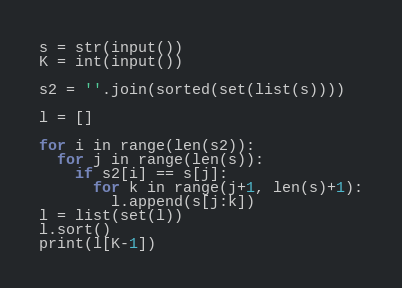Convert code to text. <code><loc_0><loc_0><loc_500><loc_500><_Python_>s = str(input())
K = int(input())

s2 = ''.join(sorted(set(list(s))))

l = []

for i in range(len(s2)):
  for j in range(len(s)):
    if s2[i] == s[j]:
      for k in range(j+1, len(s)+1):
        l.append(s[j:k])
l = list(set(l))
l.sort()
print(l[K-1])</code> 